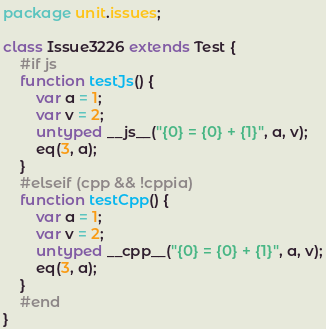<code> <loc_0><loc_0><loc_500><loc_500><_Haxe_>package unit.issues;

class Issue3226 extends Test {
	#if js
	function testJs() {
		var a = 1;
		var v = 2;
		untyped __js__("{0} = {0} + {1}", a, v);
		eq(3, a);
	}
	#elseif (cpp && !cppia)
	function testCpp() {
		var a = 1;
		var v = 2;
		untyped __cpp__("{0} = {0} + {1}", a, v);
		eq(3, a);
	}
	#end
}
</code> 